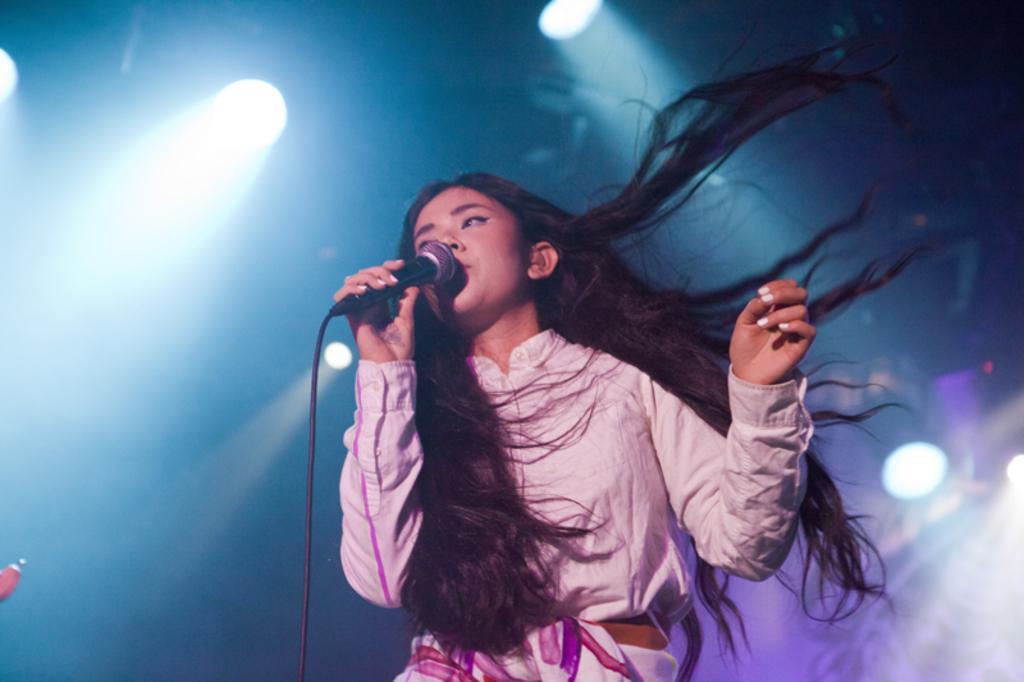Can you describe this image briefly? In the picture we can find a woman singing a song in the microphone. In the background we can find lights and a blue screen. She is wearing a light pink shirt and the black hair flying. 